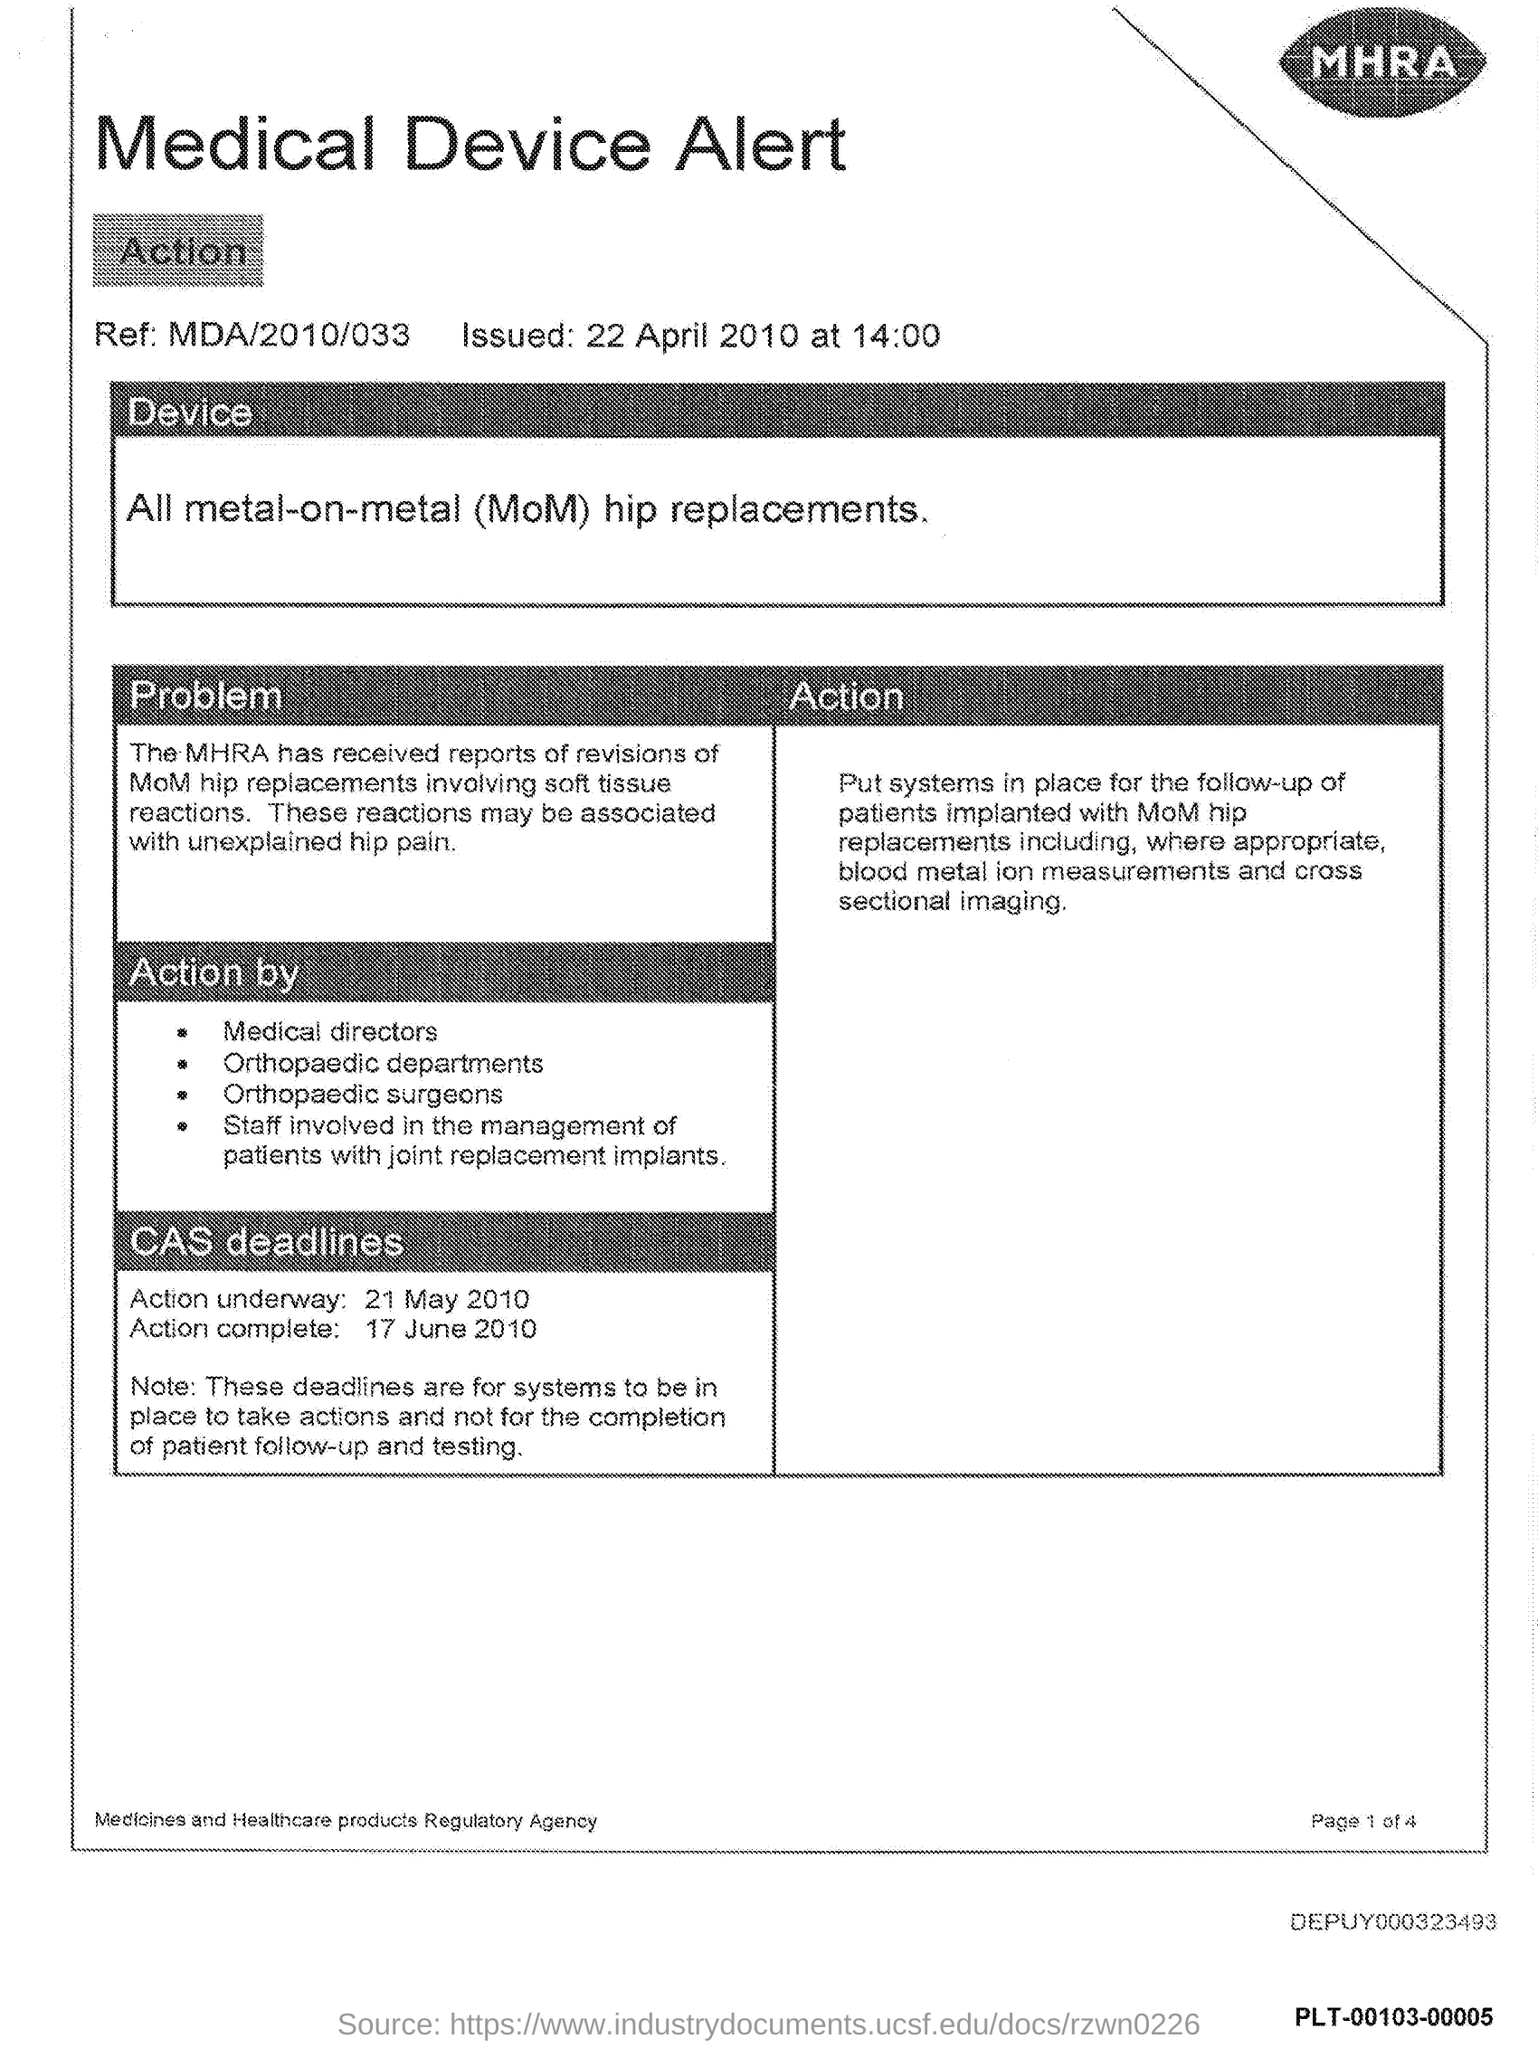What is the Reference Number?
Provide a short and direct response. MDA/2010/033. What is the date of Action Complete?
Provide a succinct answer. 17 June 2010. What is the date of Action Underway?
Provide a succinct answer. 21 May 2010. 